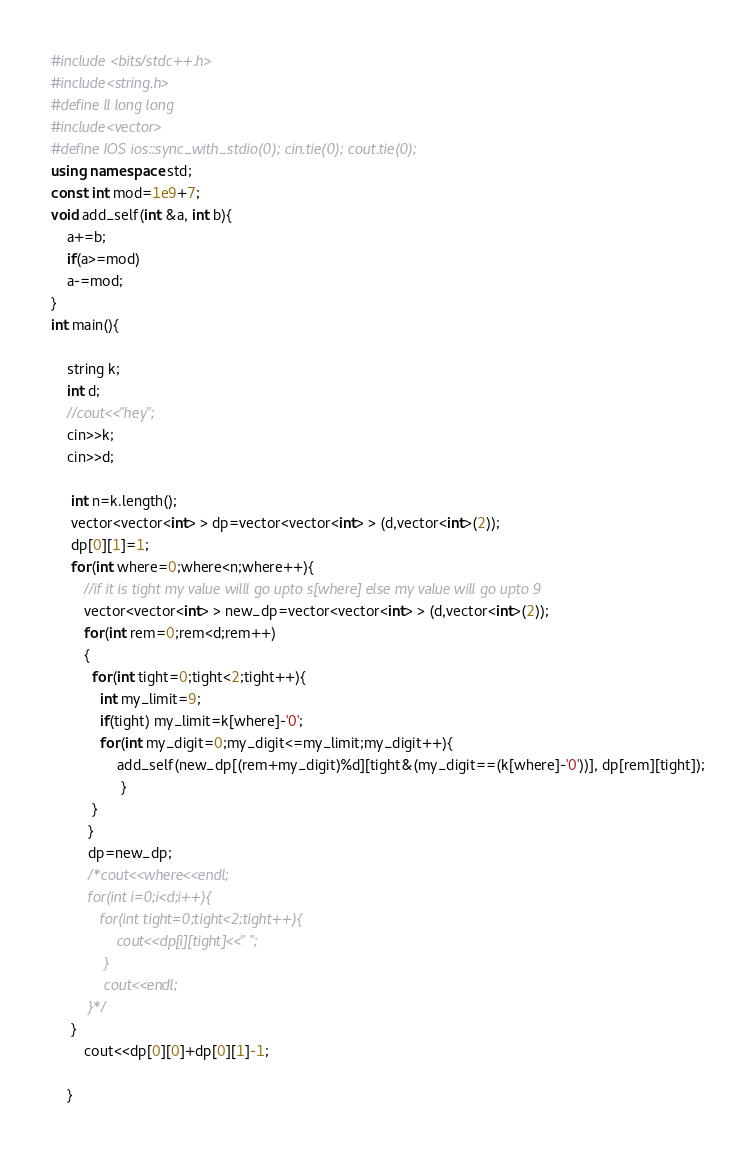Convert code to text. <code><loc_0><loc_0><loc_500><loc_500><_C++_>#include <bits/stdc++.h>
#include<string.h>
#define ll long long 
#include<vector>
#define IOS ios::sync_with_stdio(0); cin.tie(0); cout.tie(0);
using namespace std;
const int mod=1e9+7;
void add_self(int &a, int b){
	a+=b;
	if(a>=mod)
	a-=mod;
}
int main(){
	
	string k;
	int d;
	//cout<<"hey";
	cin>>k;
	cin>>d;
	
     int n=k.length();
     vector<vector<int> > dp=vector<vector<int> > (d,vector<int>(2));
     dp[0][1]=1;
     for(int where=0;where<n;where++){
     	//if it is tight my value willl go upto s[where] else my value will go upto 9
     	vector<vector<int> > new_dp=vector<vector<int> > (d,vector<int>(2));
     	for(int rem=0;rem<d;rem++)
     	{
          for(int tight=0;tight<2;tight++){
          	int my_limit=9;
          	if(tight) my_limit=k[where]-'0';
          	for(int my_digit=0;my_digit<=my_limit;my_digit++){
          		add_self(new_dp[(rem+my_digit)%d][tight&(my_digit==(k[where]-'0'))], dp[rem][tight]);
				 }
		  }
		 }
		 dp=new_dp;
		 /*cout<<where<<endl;
		 for(int i=0;i<d;i++){
		 	for(int tight=0;tight<2;tight++){
		 		cout<<dp[i][tight]<<" ";
			 }
			 cout<<endl;
		 }*/
	 }
	 	cout<<dp[0][0]+dp[0][1]-1;
		 
	}</code> 